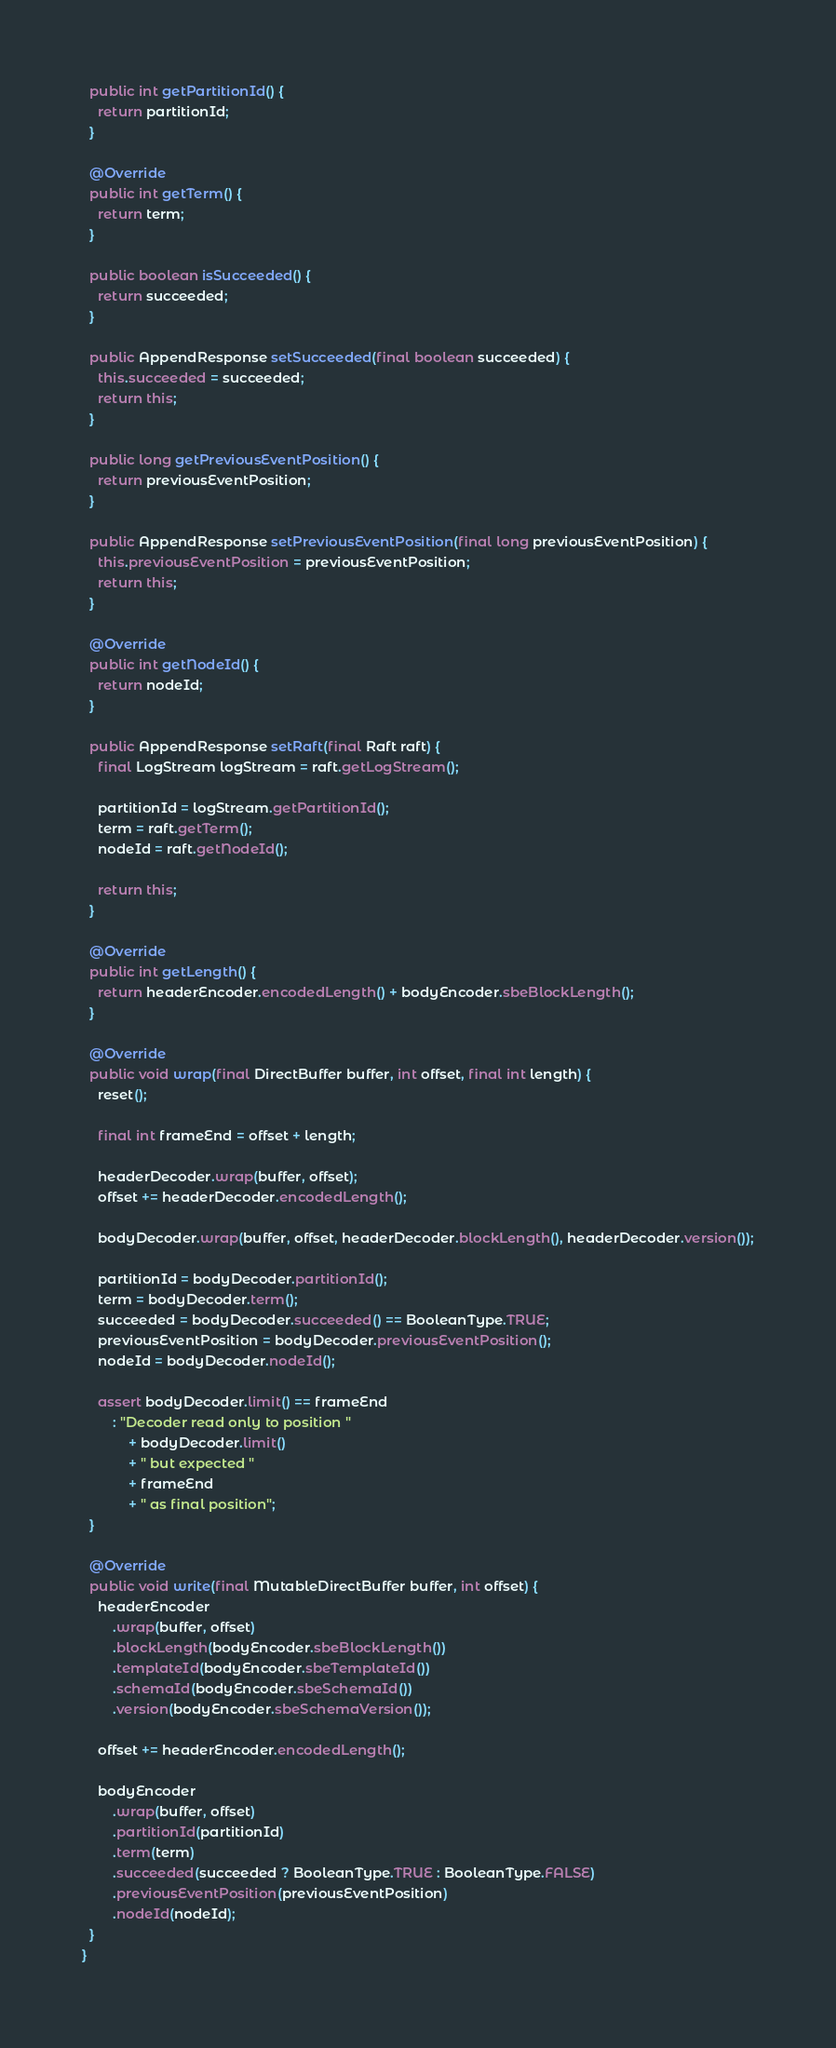<code> <loc_0><loc_0><loc_500><loc_500><_Java_>  public int getPartitionId() {
    return partitionId;
  }

  @Override
  public int getTerm() {
    return term;
  }

  public boolean isSucceeded() {
    return succeeded;
  }

  public AppendResponse setSucceeded(final boolean succeeded) {
    this.succeeded = succeeded;
    return this;
  }

  public long getPreviousEventPosition() {
    return previousEventPosition;
  }

  public AppendResponse setPreviousEventPosition(final long previousEventPosition) {
    this.previousEventPosition = previousEventPosition;
    return this;
  }

  @Override
  public int getNodeId() {
    return nodeId;
  }

  public AppendResponse setRaft(final Raft raft) {
    final LogStream logStream = raft.getLogStream();

    partitionId = logStream.getPartitionId();
    term = raft.getTerm();
    nodeId = raft.getNodeId();

    return this;
  }

  @Override
  public int getLength() {
    return headerEncoder.encodedLength() + bodyEncoder.sbeBlockLength();
  }

  @Override
  public void wrap(final DirectBuffer buffer, int offset, final int length) {
    reset();

    final int frameEnd = offset + length;

    headerDecoder.wrap(buffer, offset);
    offset += headerDecoder.encodedLength();

    bodyDecoder.wrap(buffer, offset, headerDecoder.blockLength(), headerDecoder.version());

    partitionId = bodyDecoder.partitionId();
    term = bodyDecoder.term();
    succeeded = bodyDecoder.succeeded() == BooleanType.TRUE;
    previousEventPosition = bodyDecoder.previousEventPosition();
    nodeId = bodyDecoder.nodeId();

    assert bodyDecoder.limit() == frameEnd
        : "Decoder read only to position "
            + bodyDecoder.limit()
            + " but expected "
            + frameEnd
            + " as final position";
  }

  @Override
  public void write(final MutableDirectBuffer buffer, int offset) {
    headerEncoder
        .wrap(buffer, offset)
        .blockLength(bodyEncoder.sbeBlockLength())
        .templateId(bodyEncoder.sbeTemplateId())
        .schemaId(bodyEncoder.sbeSchemaId())
        .version(bodyEncoder.sbeSchemaVersion());

    offset += headerEncoder.encodedLength();

    bodyEncoder
        .wrap(buffer, offset)
        .partitionId(partitionId)
        .term(term)
        .succeeded(succeeded ? BooleanType.TRUE : BooleanType.FALSE)
        .previousEventPosition(previousEventPosition)
        .nodeId(nodeId);
  }
}
</code> 